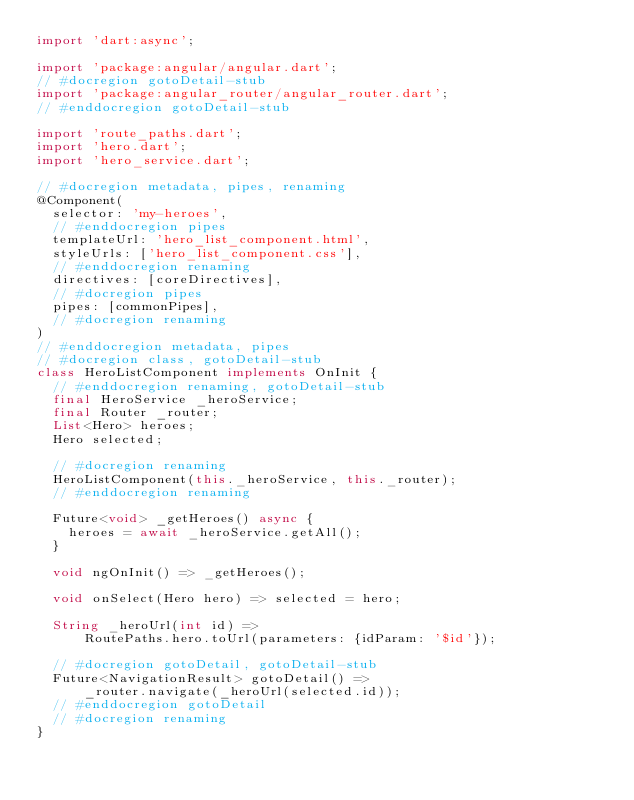<code> <loc_0><loc_0><loc_500><loc_500><_Dart_>import 'dart:async';

import 'package:angular/angular.dart';
// #docregion gotoDetail-stub
import 'package:angular_router/angular_router.dart';
// #enddocregion gotoDetail-stub

import 'route_paths.dart';
import 'hero.dart';
import 'hero_service.dart';

// #docregion metadata, pipes, renaming
@Component(
  selector: 'my-heroes',
  // #enddocregion pipes
  templateUrl: 'hero_list_component.html',
  styleUrls: ['hero_list_component.css'],
  // #enddocregion renaming
  directives: [coreDirectives],
  // #docregion pipes
  pipes: [commonPipes],
  // #docregion renaming
)
// #enddocregion metadata, pipes
// #docregion class, gotoDetail-stub
class HeroListComponent implements OnInit {
  // #enddocregion renaming, gotoDetail-stub
  final HeroService _heroService;
  final Router _router;
  List<Hero> heroes;
  Hero selected;

  // #docregion renaming
  HeroListComponent(this._heroService, this._router);
  // #enddocregion renaming

  Future<void> _getHeroes() async {
    heroes = await _heroService.getAll();
  }

  void ngOnInit() => _getHeroes();

  void onSelect(Hero hero) => selected = hero;

  String _heroUrl(int id) =>
      RoutePaths.hero.toUrl(parameters: {idParam: '$id'});

  // #docregion gotoDetail, gotoDetail-stub
  Future<NavigationResult> gotoDetail() =>
      _router.navigate(_heroUrl(selected.id));
  // #enddocregion gotoDetail
  // #docregion renaming
}
</code> 